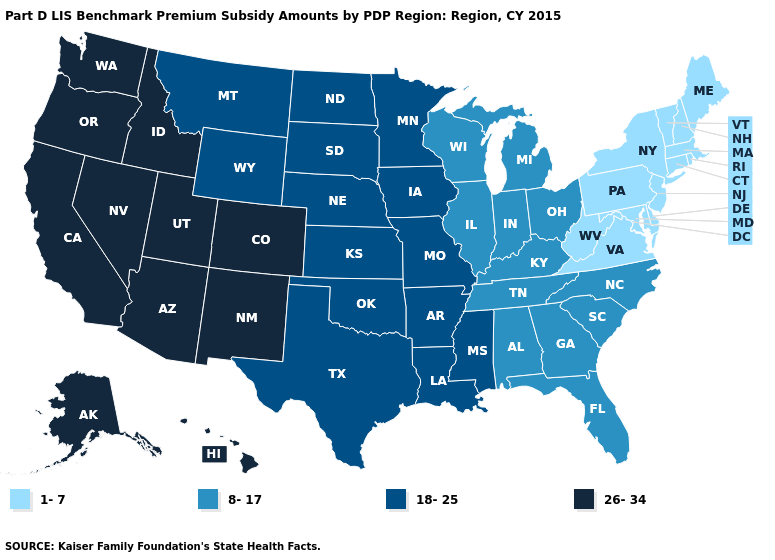Does the map have missing data?
Give a very brief answer. No. Which states have the highest value in the USA?
Concise answer only. Alaska, Arizona, California, Colorado, Hawaii, Idaho, Nevada, New Mexico, Oregon, Utah, Washington. Does the map have missing data?
Quick response, please. No. Name the states that have a value in the range 26-34?
Answer briefly. Alaska, Arizona, California, Colorado, Hawaii, Idaho, Nevada, New Mexico, Oregon, Utah, Washington. Name the states that have a value in the range 18-25?
Answer briefly. Arkansas, Iowa, Kansas, Louisiana, Minnesota, Mississippi, Missouri, Montana, Nebraska, North Dakota, Oklahoma, South Dakota, Texas, Wyoming. Among the states that border Tennessee , does Kentucky have the highest value?
Quick response, please. No. Name the states that have a value in the range 18-25?
Be succinct. Arkansas, Iowa, Kansas, Louisiana, Minnesota, Mississippi, Missouri, Montana, Nebraska, North Dakota, Oklahoma, South Dakota, Texas, Wyoming. Name the states that have a value in the range 26-34?
Short answer required. Alaska, Arizona, California, Colorado, Hawaii, Idaho, Nevada, New Mexico, Oregon, Utah, Washington. What is the lowest value in states that border Michigan?
Quick response, please. 8-17. Is the legend a continuous bar?
Keep it brief. No. Among the states that border Arkansas , which have the highest value?
Concise answer only. Louisiana, Mississippi, Missouri, Oklahoma, Texas. Which states have the lowest value in the USA?
Concise answer only. Connecticut, Delaware, Maine, Maryland, Massachusetts, New Hampshire, New Jersey, New York, Pennsylvania, Rhode Island, Vermont, Virginia, West Virginia. What is the value of Oklahoma?
Answer briefly. 18-25. Name the states that have a value in the range 1-7?
Keep it brief. Connecticut, Delaware, Maine, Maryland, Massachusetts, New Hampshire, New Jersey, New York, Pennsylvania, Rhode Island, Vermont, Virginia, West Virginia. Among the states that border Oregon , which have the lowest value?
Concise answer only. California, Idaho, Nevada, Washington. 